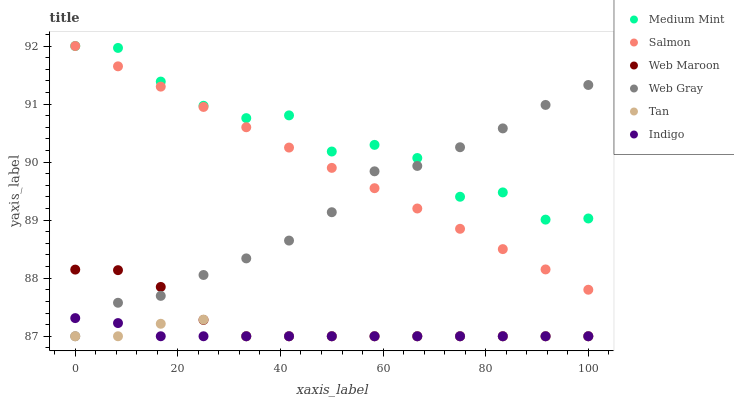Does Indigo have the minimum area under the curve?
Answer yes or no. Yes. Does Medium Mint have the maximum area under the curve?
Answer yes or no. Yes. Does Web Gray have the minimum area under the curve?
Answer yes or no. No. Does Web Gray have the maximum area under the curve?
Answer yes or no. No. Is Salmon the smoothest?
Answer yes or no. Yes. Is Medium Mint the roughest?
Answer yes or no. Yes. Is Web Gray the smoothest?
Answer yes or no. No. Is Web Gray the roughest?
Answer yes or no. No. Does Web Gray have the lowest value?
Answer yes or no. Yes. Does Salmon have the lowest value?
Answer yes or no. No. Does Salmon have the highest value?
Answer yes or no. Yes. Does Web Gray have the highest value?
Answer yes or no. No. Is Web Maroon less than Salmon?
Answer yes or no. Yes. Is Salmon greater than Tan?
Answer yes or no. Yes. Does Tan intersect Indigo?
Answer yes or no. Yes. Is Tan less than Indigo?
Answer yes or no. No. Is Tan greater than Indigo?
Answer yes or no. No. Does Web Maroon intersect Salmon?
Answer yes or no. No. 